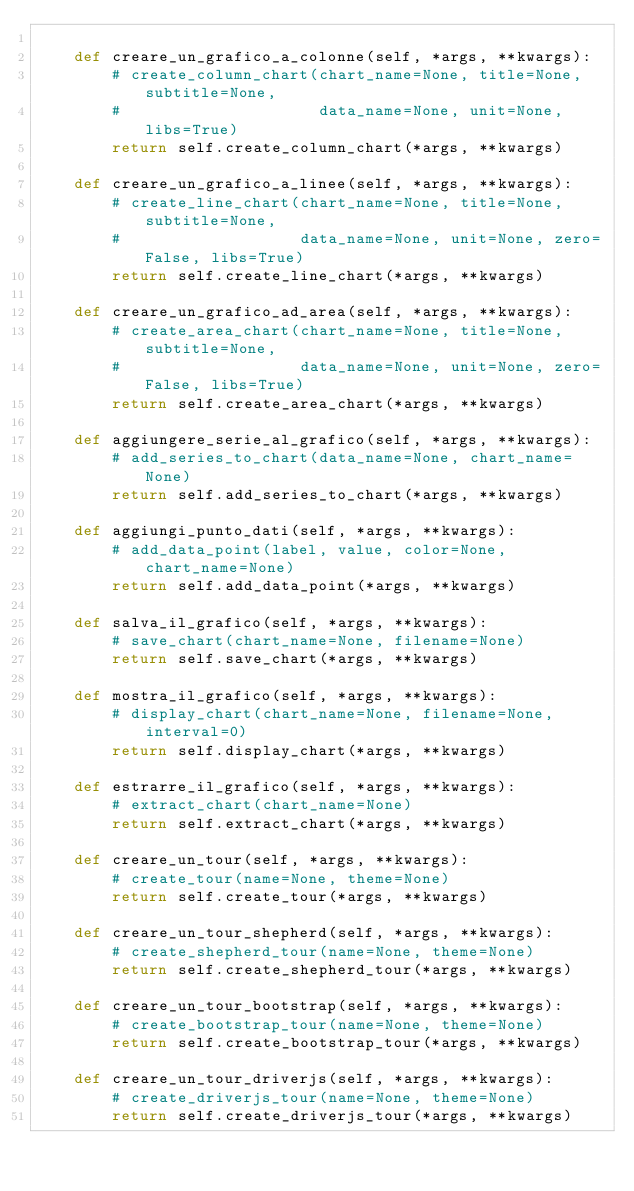<code> <loc_0><loc_0><loc_500><loc_500><_Python_>
    def creare_un_grafico_a_colonne(self, *args, **kwargs):
        # create_column_chart(chart_name=None, title=None, subtitle=None,
        #                     data_name=None, unit=None, libs=True)
        return self.create_column_chart(*args, **kwargs)

    def creare_un_grafico_a_linee(self, *args, **kwargs):
        # create_line_chart(chart_name=None, title=None, subtitle=None,
        #                   data_name=None, unit=None, zero=False, libs=True)
        return self.create_line_chart(*args, **kwargs)

    def creare_un_grafico_ad_area(self, *args, **kwargs):
        # create_area_chart(chart_name=None, title=None, subtitle=None,
        #                   data_name=None, unit=None, zero=False, libs=True)
        return self.create_area_chart(*args, **kwargs)

    def aggiungere_serie_al_grafico(self, *args, **kwargs):
        # add_series_to_chart(data_name=None, chart_name=None)
        return self.add_series_to_chart(*args, **kwargs)

    def aggiungi_punto_dati(self, *args, **kwargs):
        # add_data_point(label, value, color=None, chart_name=None)
        return self.add_data_point(*args, **kwargs)

    def salva_il_grafico(self, *args, **kwargs):
        # save_chart(chart_name=None, filename=None)
        return self.save_chart(*args, **kwargs)

    def mostra_il_grafico(self, *args, **kwargs):
        # display_chart(chart_name=None, filename=None, interval=0)
        return self.display_chart(*args, **kwargs)

    def estrarre_il_grafico(self, *args, **kwargs):
        # extract_chart(chart_name=None)
        return self.extract_chart(*args, **kwargs)

    def creare_un_tour(self, *args, **kwargs):
        # create_tour(name=None, theme=None)
        return self.create_tour(*args, **kwargs)

    def creare_un_tour_shepherd(self, *args, **kwargs):
        # create_shepherd_tour(name=None, theme=None)
        return self.create_shepherd_tour(*args, **kwargs)

    def creare_un_tour_bootstrap(self, *args, **kwargs):
        # create_bootstrap_tour(name=None, theme=None)
        return self.create_bootstrap_tour(*args, **kwargs)

    def creare_un_tour_driverjs(self, *args, **kwargs):
        # create_driverjs_tour(name=None, theme=None)
        return self.create_driverjs_tour(*args, **kwargs)
</code> 